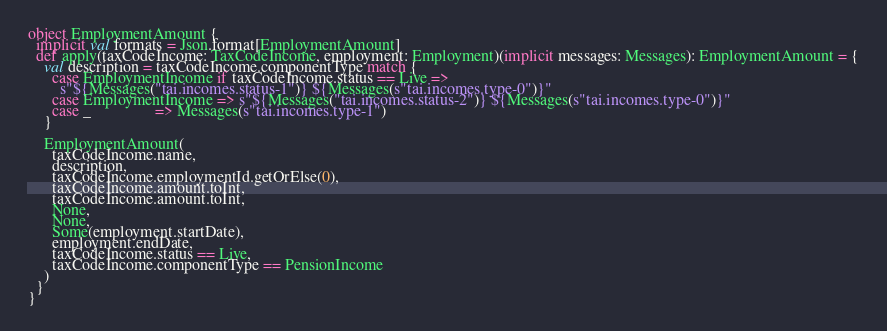<code> <loc_0><loc_0><loc_500><loc_500><_Scala_>
object EmploymentAmount {
  implicit val formats = Json.format[EmploymentAmount]
  def apply(taxCodeIncome: TaxCodeIncome, employment: Employment)(implicit messages: Messages): EmploymentAmount = {
    val description = taxCodeIncome.componentType match {
      case EmploymentIncome if taxCodeIncome.status == Live =>
        s"${Messages("tai.incomes.status-1")} ${Messages(s"tai.incomes.type-0")}"
      case EmploymentIncome => s"${Messages("tai.incomes.status-2")} ${Messages(s"tai.incomes.type-0")}"
      case _                => Messages(s"tai.incomes.type-1")
    }

    EmploymentAmount(
      taxCodeIncome.name,
      description,
      taxCodeIncome.employmentId.getOrElse(0),
      taxCodeIncome.amount.toInt,
      taxCodeIncome.amount.toInt,
      None,
      None,
      Some(employment.startDate),
      employment.endDate,
      taxCodeIncome.status == Live,
      taxCodeIncome.componentType == PensionIncome
    )
  }
}
</code> 